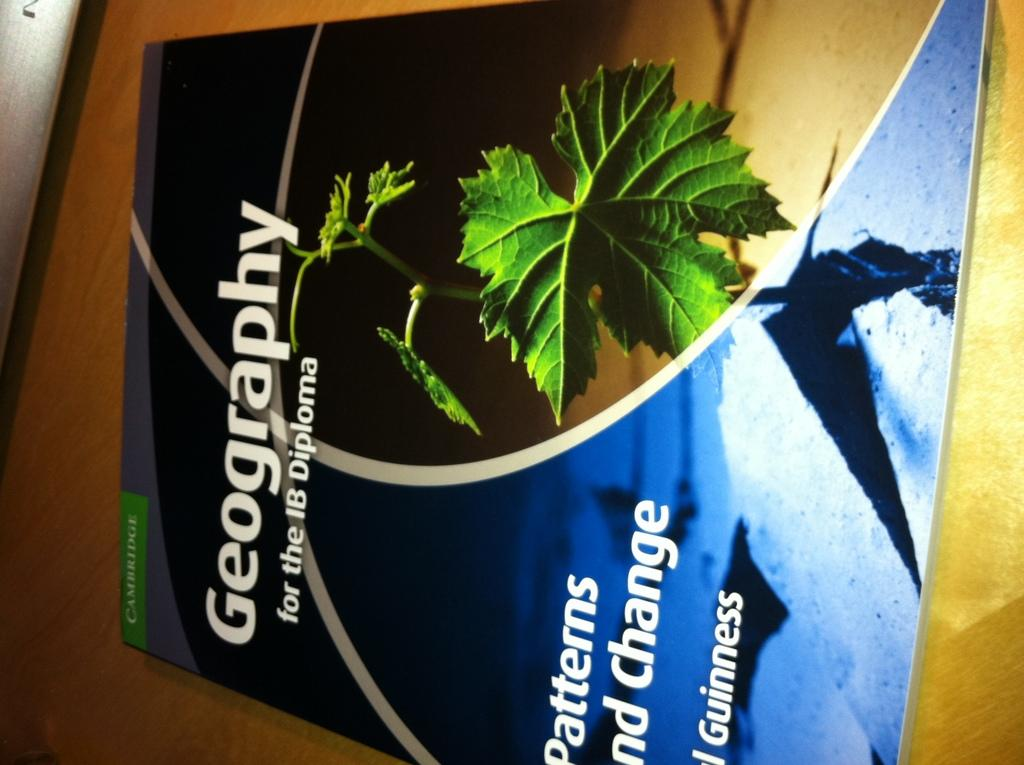<image>
Summarize the visual content of the image. A pamphlet titled, "Geography" has a picture of a leaf on it. 